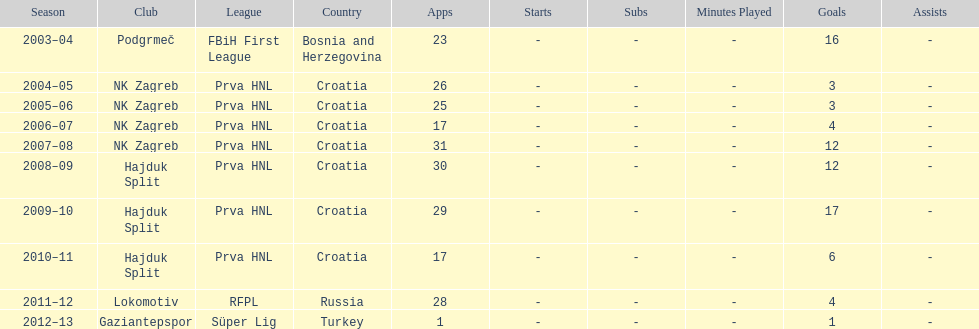At most 26 apps, how many goals were scored in 2004-2005 3. 